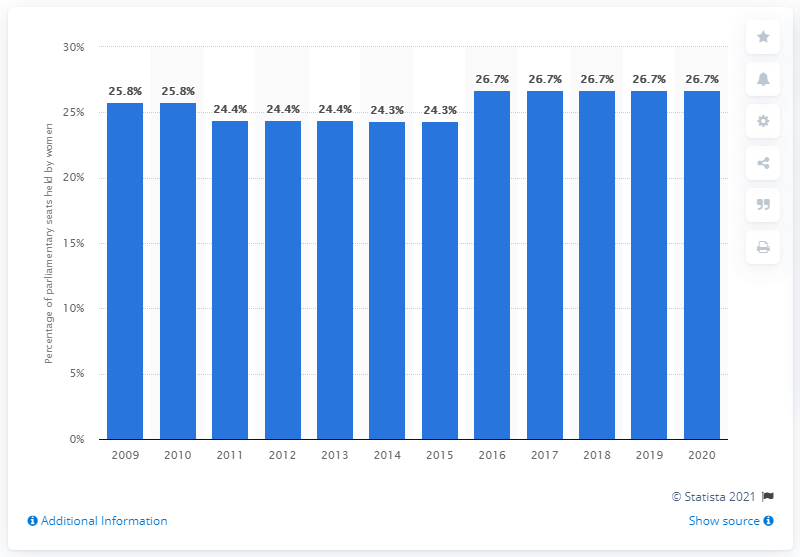Mention a couple of crucial points in this snapshot. In 2020, women filled 26.7% of the seats in parliament. In 2009, the percentage of female parliamentarians in Vietnam was 25.8%. In 2009, the percentage of female parliamentarians in Vietnam was 25.8%. 